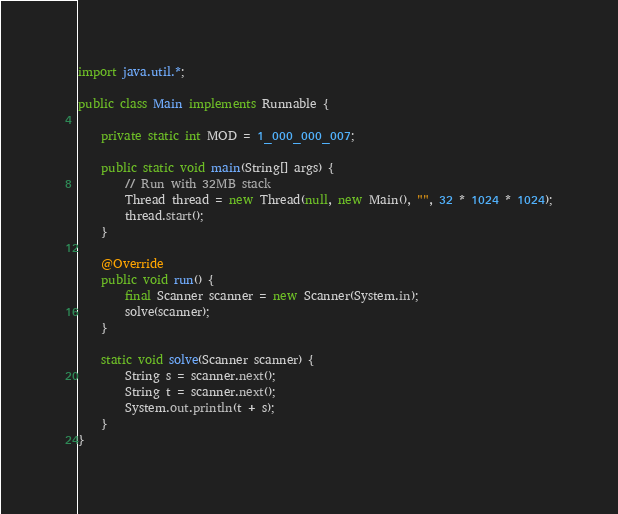<code> <loc_0><loc_0><loc_500><loc_500><_Java_>import java.util.*;

public class Main implements Runnable {

    private static int MOD = 1_000_000_007;

    public static void main(String[] args) {
        // Run with 32MB stack
        Thread thread = new Thread(null, new Main(), "", 32 * 1024 * 1024);
        thread.start();
    }

    @Override
    public void run() {
        final Scanner scanner = new Scanner(System.in);
        solve(scanner);
    }

    static void solve(Scanner scanner) {
        String s = scanner.next();
        String t = scanner.next();
        System.out.println(t + s);
    }
}
</code> 